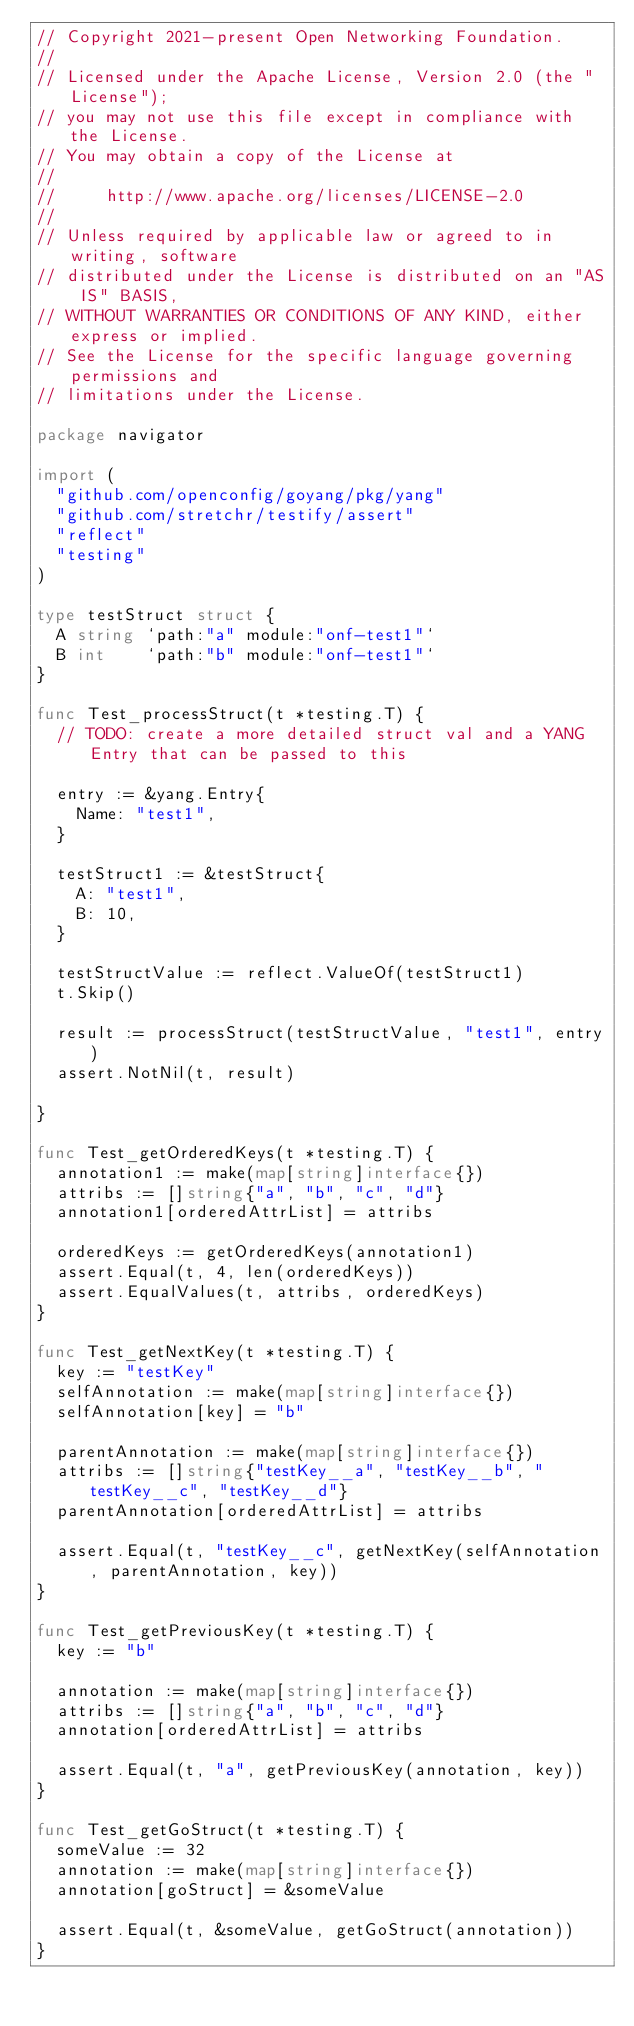Convert code to text. <code><loc_0><loc_0><loc_500><loc_500><_Go_>// Copyright 2021-present Open Networking Foundation.
//
// Licensed under the Apache License, Version 2.0 (the "License");
// you may not use this file except in compliance with the License.
// You may obtain a copy of the License at
//
//     http://www.apache.org/licenses/LICENSE-2.0
//
// Unless required by applicable law or agreed to in writing, software
// distributed under the License is distributed on an "AS IS" BASIS,
// WITHOUT WARRANTIES OR CONDITIONS OF ANY KIND, either express or implied.
// See the License for the specific language governing permissions and
// limitations under the License.

package navigator

import (
	"github.com/openconfig/goyang/pkg/yang"
	"github.com/stretchr/testify/assert"
	"reflect"
	"testing"
)

type testStruct struct {
	A string `path:"a" module:"onf-test1"`
	B int    `path:"b" module:"onf-test1"`
}

func Test_processStruct(t *testing.T) {
	// TODO: create a more detailed struct val and a YANG Entry that can be passed to this

	entry := &yang.Entry{
		Name: "test1",
	}

	testStruct1 := &testStruct{
		A: "test1",
		B: 10,
	}

	testStructValue := reflect.ValueOf(testStruct1)
	t.Skip()

	result := processStruct(testStructValue, "test1", entry)
	assert.NotNil(t, result)

}

func Test_getOrderedKeys(t *testing.T) {
	annotation1 := make(map[string]interface{})
	attribs := []string{"a", "b", "c", "d"}
	annotation1[orderedAttrList] = attribs

	orderedKeys := getOrderedKeys(annotation1)
	assert.Equal(t, 4, len(orderedKeys))
	assert.EqualValues(t, attribs, orderedKeys)
}

func Test_getNextKey(t *testing.T) {
	key := "testKey"
	selfAnnotation := make(map[string]interface{})
	selfAnnotation[key] = "b"

	parentAnnotation := make(map[string]interface{})
	attribs := []string{"testKey__a", "testKey__b", "testKey__c", "testKey__d"}
	parentAnnotation[orderedAttrList] = attribs

	assert.Equal(t, "testKey__c", getNextKey(selfAnnotation, parentAnnotation, key))
}

func Test_getPreviousKey(t *testing.T) {
	key := "b"

	annotation := make(map[string]interface{})
	attribs := []string{"a", "b", "c", "d"}
	annotation[orderedAttrList] = attribs

	assert.Equal(t, "a", getPreviousKey(annotation, key))
}

func Test_getGoStruct(t *testing.T) {
	someValue := 32
	annotation := make(map[string]interface{})
	annotation[goStruct] = &someValue

	assert.Equal(t, &someValue, getGoStruct(annotation))
}
</code> 